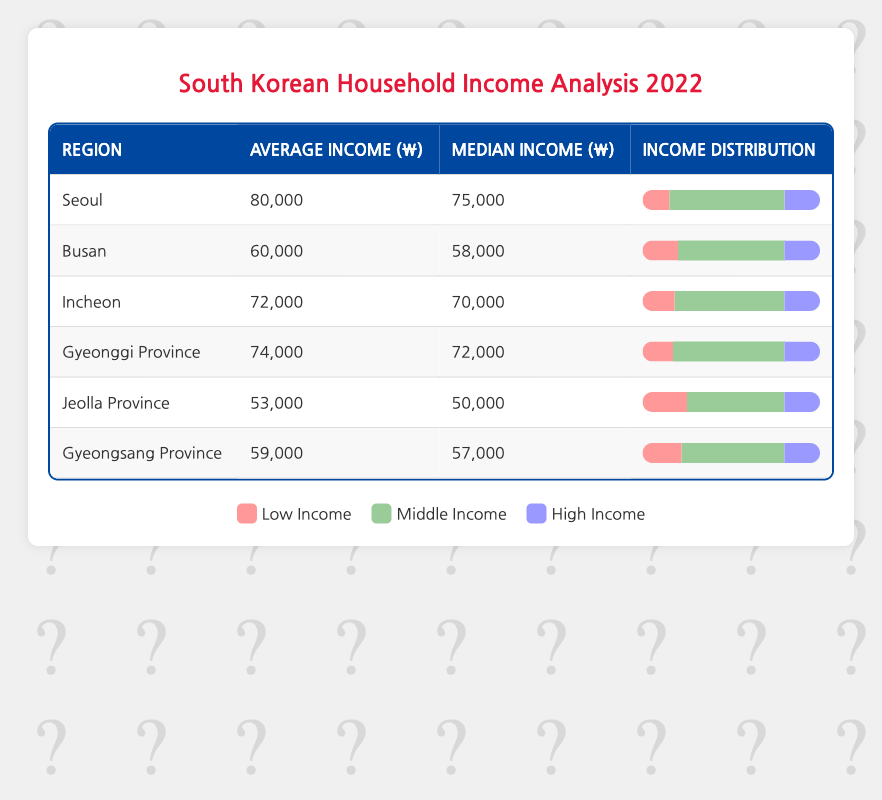What is the average income of households in Seoul in 2022? The table indicates that the average income for the region of Seoul is 80,000.
Answer: 80,000 Which region has the highest median income in 2022? The median incomes for each region are: Seoul (75,000), Busan (58,000), Incheon (70,000), Gyeonggi Province (72,000), Jeolla Province (50,000), and Gyeongsang Province (57,000). The highest median income is in Seoul with 75,000.
Answer: Seoul What percentage of households in Gyeongsang Province fall into the low-income category? The table states that in Gyeongsang Province, 22% of households fall under the low-income category.
Answer: 22% Is it true that the average income in Jeolla Province is lower than in Busan? The average income in Jeolla Province is 53,000 while that in Busan is 60,000. Since 53,000 is less than 60,000, the statement is true.
Answer: Yes What is the total percentage of low-income households across all regions? The percentages of low-income households are: Seoul (15), Busan (20), Incheon (18), Gyeonggi Province (17), Jeolla Province (25), and Gyeongsang Province (22). Summing these values gives 15 + 20 + 18 + 17 + 25 + 22 = 117, which means the total percentage is 117.
Answer: 117 Which region has the same percentage of high-income households, and what is that percentage? The table shows that all regions have 20% of households categorized as high-income. Thus, they are all the same in this regard.
Answer: 20 What is the average of the median incomes of households in Busan and Incheon? The median incomes for Busan and Incheon are 58,000 and 70,000, respectively. To find the average: (58,000 + 70,000) / 2 = 64,000.
Answer: 64,000 Which region has the lowest average income in 2022? The average incomes by region are: Seoul (80,000), Busan (60,000), Incheon (72,000), Gyeonggi Province (74,000), Jeolla Province (53,000), and Gyeongsang Province (59,000). Therefore, Jeolla Province has the lowest average income of 53,000.
Answer: Jeolla Province What percentage of households in Gyeonggi Province are in the middle-income category? The income distribution for Gyeonggi Province indicates that 63% of households fall under the middle-income category.
Answer: 63% 